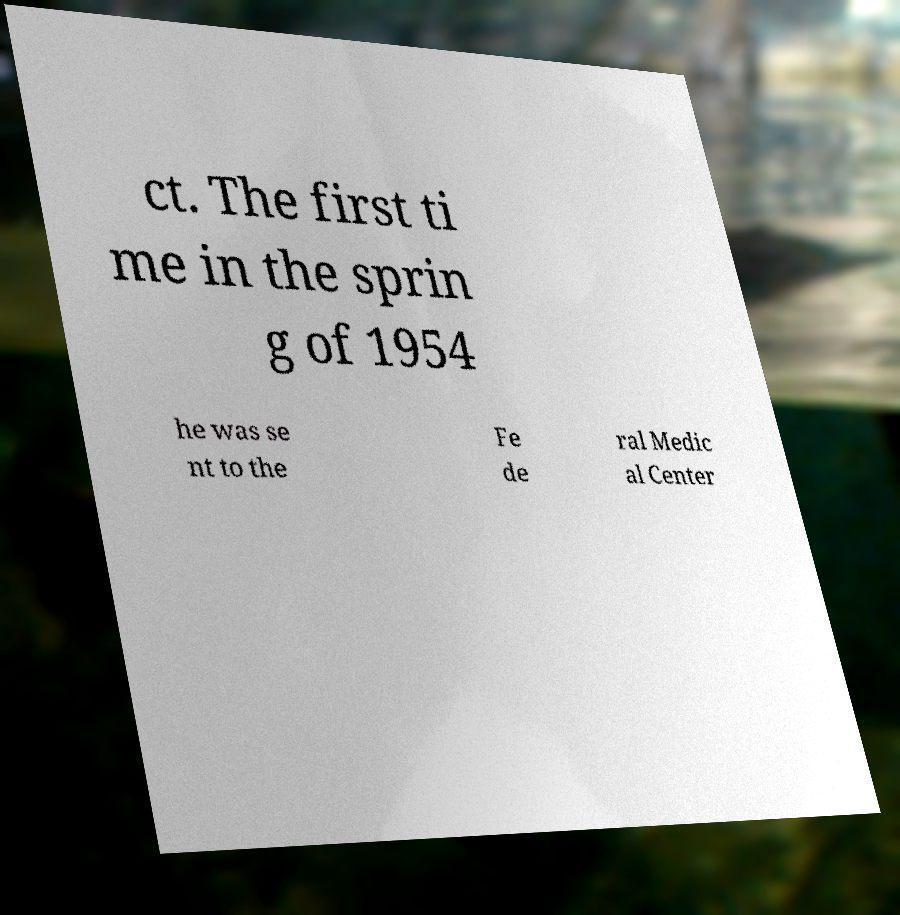Please identify and transcribe the text found in this image. ct. The first ti me in the sprin g of 1954 he was se nt to the Fe de ral Medic al Center 